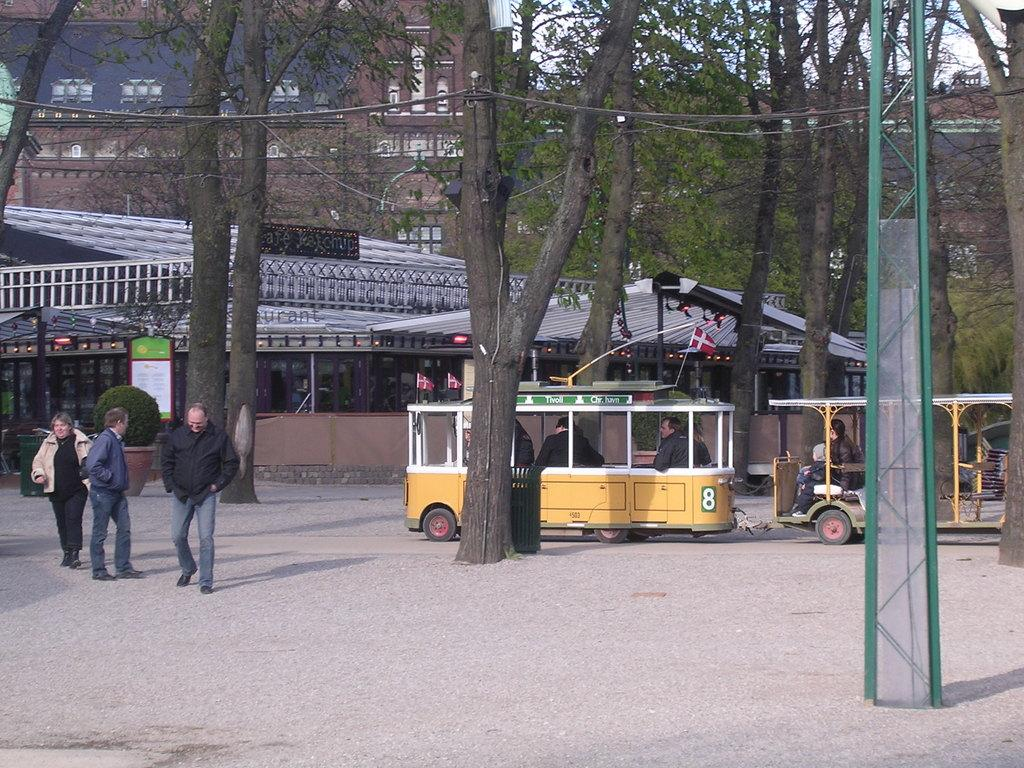<image>
Write a terse but informative summary of the picture. A tram has the word Tivoli on top of it and is moving people to a building. 